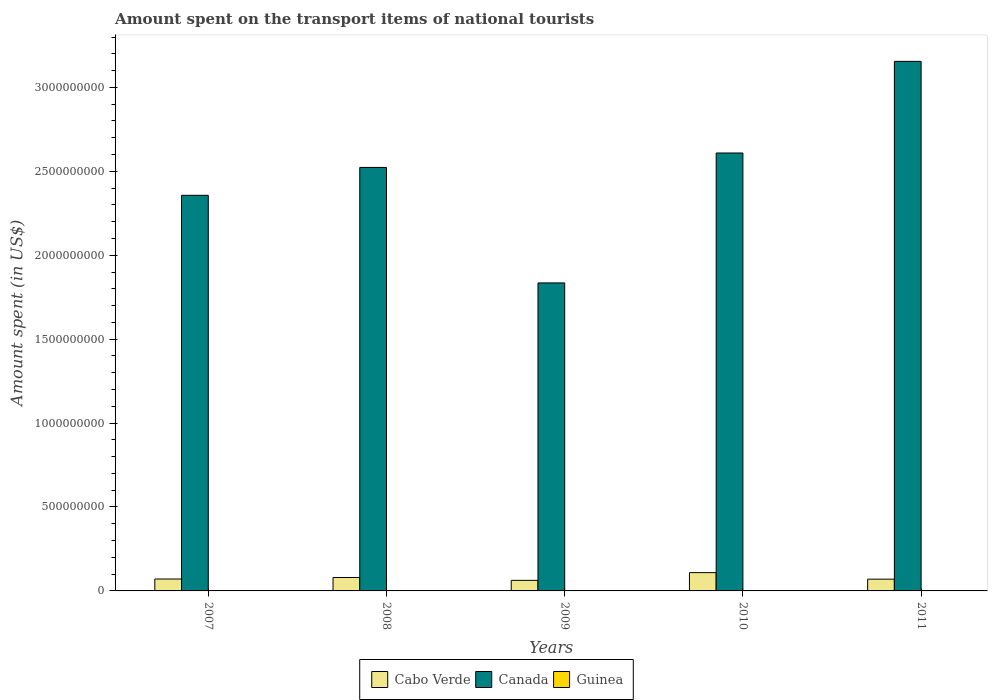How many groups of bars are there?
Give a very brief answer. 5. Are the number of bars per tick equal to the number of legend labels?
Your answer should be compact. Yes. Are the number of bars on each tick of the X-axis equal?
Provide a succinct answer. Yes. How many bars are there on the 2nd tick from the right?
Your response must be concise. 3. Across all years, what is the maximum amount spent on the transport items of national tourists in Guinea?
Offer a very short reply. 2.10e+06. Across all years, what is the minimum amount spent on the transport items of national tourists in Canada?
Your answer should be compact. 1.84e+09. What is the total amount spent on the transport items of national tourists in Cabo Verde in the graph?
Your answer should be very brief. 3.93e+08. What is the difference between the amount spent on the transport items of national tourists in Guinea in 2007 and that in 2008?
Your answer should be very brief. 0. What is the difference between the amount spent on the transport items of national tourists in Canada in 2007 and the amount spent on the transport items of national tourists in Guinea in 2010?
Your answer should be compact. 2.36e+09. What is the average amount spent on the transport items of national tourists in Guinea per year?
Your answer should be compact. 7.92e+05. In the year 2009, what is the difference between the amount spent on the transport items of national tourists in Canada and amount spent on the transport items of national tourists in Cabo Verde?
Offer a terse response. 1.77e+09. In how many years, is the amount spent on the transport items of national tourists in Cabo Verde greater than 900000000 US$?
Keep it short and to the point. 0. What is the ratio of the amount spent on the transport items of national tourists in Guinea in 2008 to that in 2011?
Give a very brief answer. 45. What is the difference between the highest and the second highest amount spent on the transport items of national tourists in Cabo Verde?
Your answer should be very brief. 2.90e+07. What is the difference between the highest and the lowest amount spent on the transport items of national tourists in Guinea?
Ensure brevity in your answer.  2.08e+06. In how many years, is the amount spent on the transport items of national tourists in Canada greater than the average amount spent on the transport items of national tourists in Canada taken over all years?
Make the answer very short. 3. What does the 3rd bar from the left in 2008 represents?
Provide a short and direct response. Guinea. What does the 3rd bar from the right in 2008 represents?
Provide a short and direct response. Cabo Verde. Is it the case that in every year, the sum of the amount spent on the transport items of national tourists in Canada and amount spent on the transport items of national tourists in Cabo Verde is greater than the amount spent on the transport items of national tourists in Guinea?
Give a very brief answer. Yes. How many bars are there?
Offer a very short reply. 15. Are the values on the major ticks of Y-axis written in scientific E-notation?
Provide a short and direct response. No. Does the graph contain any zero values?
Offer a very short reply. No. Does the graph contain grids?
Give a very brief answer. No. How many legend labels are there?
Ensure brevity in your answer.  3. How are the legend labels stacked?
Offer a very short reply. Horizontal. What is the title of the graph?
Offer a very short reply. Amount spent on the transport items of national tourists. Does "Bermuda" appear as one of the legend labels in the graph?
Your answer should be compact. No. What is the label or title of the X-axis?
Make the answer very short. Years. What is the label or title of the Y-axis?
Your answer should be compact. Amount spent (in US$). What is the Amount spent (in US$) of Cabo Verde in 2007?
Offer a terse response. 7.10e+07. What is the Amount spent (in US$) of Canada in 2007?
Provide a short and direct response. 2.36e+09. What is the Amount spent (in US$) in Cabo Verde in 2008?
Provide a succinct answer. 8.00e+07. What is the Amount spent (in US$) of Canada in 2008?
Offer a very short reply. 2.52e+09. What is the Amount spent (in US$) of Cabo Verde in 2009?
Offer a very short reply. 6.30e+07. What is the Amount spent (in US$) of Canada in 2009?
Make the answer very short. 1.84e+09. What is the Amount spent (in US$) of Guinea in 2009?
Your answer should be compact. 2.10e+06. What is the Amount spent (in US$) of Cabo Verde in 2010?
Your answer should be very brief. 1.09e+08. What is the Amount spent (in US$) of Canada in 2010?
Keep it short and to the point. 2.61e+09. What is the Amount spent (in US$) of Guinea in 2010?
Offer a very short reply. 4.00e+04. What is the Amount spent (in US$) in Cabo Verde in 2011?
Offer a very short reply. 7.00e+07. What is the Amount spent (in US$) of Canada in 2011?
Keep it short and to the point. 3.16e+09. Across all years, what is the maximum Amount spent (in US$) in Cabo Verde?
Offer a terse response. 1.09e+08. Across all years, what is the maximum Amount spent (in US$) of Canada?
Provide a short and direct response. 3.16e+09. Across all years, what is the maximum Amount spent (in US$) of Guinea?
Keep it short and to the point. 2.10e+06. Across all years, what is the minimum Amount spent (in US$) of Cabo Verde?
Give a very brief answer. 6.30e+07. Across all years, what is the minimum Amount spent (in US$) in Canada?
Keep it short and to the point. 1.84e+09. What is the total Amount spent (in US$) of Cabo Verde in the graph?
Offer a terse response. 3.93e+08. What is the total Amount spent (in US$) in Canada in the graph?
Your answer should be compact. 1.25e+1. What is the total Amount spent (in US$) in Guinea in the graph?
Give a very brief answer. 3.96e+06. What is the difference between the Amount spent (in US$) in Cabo Verde in 2007 and that in 2008?
Ensure brevity in your answer.  -9.00e+06. What is the difference between the Amount spent (in US$) of Canada in 2007 and that in 2008?
Ensure brevity in your answer.  -1.66e+08. What is the difference between the Amount spent (in US$) of Cabo Verde in 2007 and that in 2009?
Offer a terse response. 8.00e+06. What is the difference between the Amount spent (in US$) in Canada in 2007 and that in 2009?
Provide a short and direct response. 5.22e+08. What is the difference between the Amount spent (in US$) of Guinea in 2007 and that in 2009?
Your answer should be compact. -1.20e+06. What is the difference between the Amount spent (in US$) in Cabo Verde in 2007 and that in 2010?
Ensure brevity in your answer.  -3.80e+07. What is the difference between the Amount spent (in US$) of Canada in 2007 and that in 2010?
Make the answer very short. -2.52e+08. What is the difference between the Amount spent (in US$) in Guinea in 2007 and that in 2010?
Give a very brief answer. 8.60e+05. What is the difference between the Amount spent (in US$) of Canada in 2007 and that in 2011?
Your answer should be compact. -7.98e+08. What is the difference between the Amount spent (in US$) of Guinea in 2007 and that in 2011?
Keep it short and to the point. 8.80e+05. What is the difference between the Amount spent (in US$) in Cabo Verde in 2008 and that in 2009?
Provide a short and direct response. 1.70e+07. What is the difference between the Amount spent (in US$) in Canada in 2008 and that in 2009?
Your answer should be very brief. 6.88e+08. What is the difference between the Amount spent (in US$) of Guinea in 2008 and that in 2009?
Provide a succinct answer. -1.20e+06. What is the difference between the Amount spent (in US$) of Cabo Verde in 2008 and that in 2010?
Keep it short and to the point. -2.90e+07. What is the difference between the Amount spent (in US$) of Canada in 2008 and that in 2010?
Provide a succinct answer. -8.60e+07. What is the difference between the Amount spent (in US$) of Guinea in 2008 and that in 2010?
Provide a succinct answer. 8.60e+05. What is the difference between the Amount spent (in US$) in Cabo Verde in 2008 and that in 2011?
Ensure brevity in your answer.  1.00e+07. What is the difference between the Amount spent (in US$) in Canada in 2008 and that in 2011?
Give a very brief answer. -6.32e+08. What is the difference between the Amount spent (in US$) of Guinea in 2008 and that in 2011?
Give a very brief answer. 8.80e+05. What is the difference between the Amount spent (in US$) in Cabo Verde in 2009 and that in 2010?
Keep it short and to the point. -4.60e+07. What is the difference between the Amount spent (in US$) of Canada in 2009 and that in 2010?
Your response must be concise. -7.74e+08. What is the difference between the Amount spent (in US$) of Guinea in 2009 and that in 2010?
Offer a very short reply. 2.06e+06. What is the difference between the Amount spent (in US$) in Cabo Verde in 2009 and that in 2011?
Offer a terse response. -7.00e+06. What is the difference between the Amount spent (in US$) in Canada in 2009 and that in 2011?
Offer a terse response. -1.32e+09. What is the difference between the Amount spent (in US$) of Guinea in 2009 and that in 2011?
Provide a succinct answer. 2.08e+06. What is the difference between the Amount spent (in US$) in Cabo Verde in 2010 and that in 2011?
Your answer should be very brief. 3.90e+07. What is the difference between the Amount spent (in US$) in Canada in 2010 and that in 2011?
Keep it short and to the point. -5.46e+08. What is the difference between the Amount spent (in US$) of Cabo Verde in 2007 and the Amount spent (in US$) of Canada in 2008?
Ensure brevity in your answer.  -2.45e+09. What is the difference between the Amount spent (in US$) of Cabo Verde in 2007 and the Amount spent (in US$) of Guinea in 2008?
Provide a short and direct response. 7.01e+07. What is the difference between the Amount spent (in US$) in Canada in 2007 and the Amount spent (in US$) in Guinea in 2008?
Offer a terse response. 2.36e+09. What is the difference between the Amount spent (in US$) of Cabo Verde in 2007 and the Amount spent (in US$) of Canada in 2009?
Your answer should be very brief. -1.76e+09. What is the difference between the Amount spent (in US$) of Cabo Verde in 2007 and the Amount spent (in US$) of Guinea in 2009?
Your response must be concise. 6.89e+07. What is the difference between the Amount spent (in US$) in Canada in 2007 and the Amount spent (in US$) in Guinea in 2009?
Offer a very short reply. 2.35e+09. What is the difference between the Amount spent (in US$) of Cabo Verde in 2007 and the Amount spent (in US$) of Canada in 2010?
Offer a very short reply. -2.54e+09. What is the difference between the Amount spent (in US$) of Cabo Verde in 2007 and the Amount spent (in US$) of Guinea in 2010?
Ensure brevity in your answer.  7.10e+07. What is the difference between the Amount spent (in US$) of Canada in 2007 and the Amount spent (in US$) of Guinea in 2010?
Offer a very short reply. 2.36e+09. What is the difference between the Amount spent (in US$) in Cabo Verde in 2007 and the Amount spent (in US$) in Canada in 2011?
Offer a very short reply. -3.08e+09. What is the difference between the Amount spent (in US$) in Cabo Verde in 2007 and the Amount spent (in US$) in Guinea in 2011?
Your answer should be compact. 7.10e+07. What is the difference between the Amount spent (in US$) in Canada in 2007 and the Amount spent (in US$) in Guinea in 2011?
Offer a very short reply. 2.36e+09. What is the difference between the Amount spent (in US$) in Cabo Verde in 2008 and the Amount spent (in US$) in Canada in 2009?
Ensure brevity in your answer.  -1.76e+09. What is the difference between the Amount spent (in US$) in Cabo Verde in 2008 and the Amount spent (in US$) in Guinea in 2009?
Your response must be concise. 7.79e+07. What is the difference between the Amount spent (in US$) of Canada in 2008 and the Amount spent (in US$) of Guinea in 2009?
Provide a succinct answer. 2.52e+09. What is the difference between the Amount spent (in US$) of Cabo Verde in 2008 and the Amount spent (in US$) of Canada in 2010?
Provide a short and direct response. -2.53e+09. What is the difference between the Amount spent (in US$) in Cabo Verde in 2008 and the Amount spent (in US$) in Guinea in 2010?
Make the answer very short. 8.00e+07. What is the difference between the Amount spent (in US$) of Canada in 2008 and the Amount spent (in US$) of Guinea in 2010?
Your answer should be compact. 2.52e+09. What is the difference between the Amount spent (in US$) of Cabo Verde in 2008 and the Amount spent (in US$) of Canada in 2011?
Ensure brevity in your answer.  -3.08e+09. What is the difference between the Amount spent (in US$) of Cabo Verde in 2008 and the Amount spent (in US$) of Guinea in 2011?
Your response must be concise. 8.00e+07. What is the difference between the Amount spent (in US$) in Canada in 2008 and the Amount spent (in US$) in Guinea in 2011?
Make the answer very short. 2.52e+09. What is the difference between the Amount spent (in US$) of Cabo Verde in 2009 and the Amount spent (in US$) of Canada in 2010?
Your response must be concise. -2.55e+09. What is the difference between the Amount spent (in US$) of Cabo Verde in 2009 and the Amount spent (in US$) of Guinea in 2010?
Offer a terse response. 6.30e+07. What is the difference between the Amount spent (in US$) of Canada in 2009 and the Amount spent (in US$) of Guinea in 2010?
Offer a terse response. 1.83e+09. What is the difference between the Amount spent (in US$) in Cabo Verde in 2009 and the Amount spent (in US$) in Canada in 2011?
Provide a short and direct response. -3.09e+09. What is the difference between the Amount spent (in US$) of Cabo Verde in 2009 and the Amount spent (in US$) of Guinea in 2011?
Offer a very short reply. 6.30e+07. What is the difference between the Amount spent (in US$) of Canada in 2009 and the Amount spent (in US$) of Guinea in 2011?
Your answer should be compact. 1.83e+09. What is the difference between the Amount spent (in US$) in Cabo Verde in 2010 and the Amount spent (in US$) in Canada in 2011?
Provide a short and direct response. -3.05e+09. What is the difference between the Amount spent (in US$) of Cabo Verde in 2010 and the Amount spent (in US$) of Guinea in 2011?
Your answer should be compact. 1.09e+08. What is the difference between the Amount spent (in US$) in Canada in 2010 and the Amount spent (in US$) in Guinea in 2011?
Offer a terse response. 2.61e+09. What is the average Amount spent (in US$) in Cabo Verde per year?
Offer a very short reply. 7.86e+07. What is the average Amount spent (in US$) of Canada per year?
Your response must be concise. 2.50e+09. What is the average Amount spent (in US$) in Guinea per year?
Ensure brevity in your answer.  7.92e+05. In the year 2007, what is the difference between the Amount spent (in US$) of Cabo Verde and Amount spent (in US$) of Canada?
Make the answer very short. -2.29e+09. In the year 2007, what is the difference between the Amount spent (in US$) in Cabo Verde and Amount spent (in US$) in Guinea?
Keep it short and to the point. 7.01e+07. In the year 2007, what is the difference between the Amount spent (in US$) of Canada and Amount spent (in US$) of Guinea?
Make the answer very short. 2.36e+09. In the year 2008, what is the difference between the Amount spent (in US$) in Cabo Verde and Amount spent (in US$) in Canada?
Keep it short and to the point. -2.44e+09. In the year 2008, what is the difference between the Amount spent (in US$) in Cabo Verde and Amount spent (in US$) in Guinea?
Give a very brief answer. 7.91e+07. In the year 2008, what is the difference between the Amount spent (in US$) in Canada and Amount spent (in US$) in Guinea?
Your answer should be compact. 2.52e+09. In the year 2009, what is the difference between the Amount spent (in US$) in Cabo Verde and Amount spent (in US$) in Canada?
Offer a very short reply. -1.77e+09. In the year 2009, what is the difference between the Amount spent (in US$) in Cabo Verde and Amount spent (in US$) in Guinea?
Provide a short and direct response. 6.09e+07. In the year 2009, what is the difference between the Amount spent (in US$) of Canada and Amount spent (in US$) of Guinea?
Provide a short and direct response. 1.83e+09. In the year 2010, what is the difference between the Amount spent (in US$) in Cabo Verde and Amount spent (in US$) in Canada?
Offer a terse response. -2.50e+09. In the year 2010, what is the difference between the Amount spent (in US$) of Cabo Verde and Amount spent (in US$) of Guinea?
Make the answer very short. 1.09e+08. In the year 2010, what is the difference between the Amount spent (in US$) in Canada and Amount spent (in US$) in Guinea?
Ensure brevity in your answer.  2.61e+09. In the year 2011, what is the difference between the Amount spent (in US$) in Cabo Verde and Amount spent (in US$) in Canada?
Your response must be concise. -3.08e+09. In the year 2011, what is the difference between the Amount spent (in US$) of Cabo Verde and Amount spent (in US$) of Guinea?
Your response must be concise. 7.00e+07. In the year 2011, what is the difference between the Amount spent (in US$) of Canada and Amount spent (in US$) of Guinea?
Keep it short and to the point. 3.15e+09. What is the ratio of the Amount spent (in US$) in Cabo Verde in 2007 to that in 2008?
Provide a short and direct response. 0.89. What is the ratio of the Amount spent (in US$) of Canada in 2007 to that in 2008?
Offer a very short reply. 0.93. What is the ratio of the Amount spent (in US$) in Guinea in 2007 to that in 2008?
Give a very brief answer. 1. What is the ratio of the Amount spent (in US$) in Cabo Verde in 2007 to that in 2009?
Ensure brevity in your answer.  1.13. What is the ratio of the Amount spent (in US$) of Canada in 2007 to that in 2009?
Provide a short and direct response. 1.28. What is the ratio of the Amount spent (in US$) in Guinea in 2007 to that in 2009?
Offer a terse response. 0.43. What is the ratio of the Amount spent (in US$) of Cabo Verde in 2007 to that in 2010?
Make the answer very short. 0.65. What is the ratio of the Amount spent (in US$) of Canada in 2007 to that in 2010?
Keep it short and to the point. 0.9. What is the ratio of the Amount spent (in US$) of Cabo Verde in 2007 to that in 2011?
Offer a terse response. 1.01. What is the ratio of the Amount spent (in US$) of Canada in 2007 to that in 2011?
Offer a terse response. 0.75. What is the ratio of the Amount spent (in US$) in Cabo Verde in 2008 to that in 2009?
Your answer should be compact. 1.27. What is the ratio of the Amount spent (in US$) of Canada in 2008 to that in 2009?
Provide a short and direct response. 1.37. What is the ratio of the Amount spent (in US$) of Guinea in 2008 to that in 2009?
Your answer should be compact. 0.43. What is the ratio of the Amount spent (in US$) of Cabo Verde in 2008 to that in 2010?
Provide a succinct answer. 0.73. What is the ratio of the Amount spent (in US$) of Canada in 2008 to that in 2010?
Provide a short and direct response. 0.97. What is the ratio of the Amount spent (in US$) in Guinea in 2008 to that in 2010?
Your response must be concise. 22.5. What is the ratio of the Amount spent (in US$) of Canada in 2008 to that in 2011?
Offer a terse response. 0.8. What is the ratio of the Amount spent (in US$) of Cabo Verde in 2009 to that in 2010?
Offer a terse response. 0.58. What is the ratio of the Amount spent (in US$) of Canada in 2009 to that in 2010?
Provide a short and direct response. 0.7. What is the ratio of the Amount spent (in US$) in Guinea in 2009 to that in 2010?
Make the answer very short. 52.5. What is the ratio of the Amount spent (in US$) of Canada in 2009 to that in 2011?
Ensure brevity in your answer.  0.58. What is the ratio of the Amount spent (in US$) of Guinea in 2009 to that in 2011?
Your response must be concise. 105. What is the ratio of the Amount spent (in US$) in Cabo Verde in 2010 to that in 2011?
Offer a very short reply. 1.56. What is the ratio of the Amount spent (in US$) in Canada in 2010 to that in 2011?
Your response must be concise. 0.83. What is the difference between the highest and the second highest Amount spent (in US$) of Cabo Verde?
Your answer should be compact. 2.90e+07. What is the difference between the highest and the second highest Amount spent (in US$) of Canada?
Offer a very short reply. 5.46e+08. What is the difference between the highest and the second highest Amount spent (in US$) of Guinea?
Keep it short and to the point. 1.20e+06. What is the difference between the highest and the lowest Amount spent (in US$) in Cabo Verde?
Your answer should be compact. 4.60e+07. What is the difference between the highest and the lowest Amount spent (in US$) in Canada?
Offer a terse response. 1.32e+09. What is the difference between the highest and the lowest Amount spent (in US$) in Guinea?
Provide a succinct answer. 2.08e+06. 